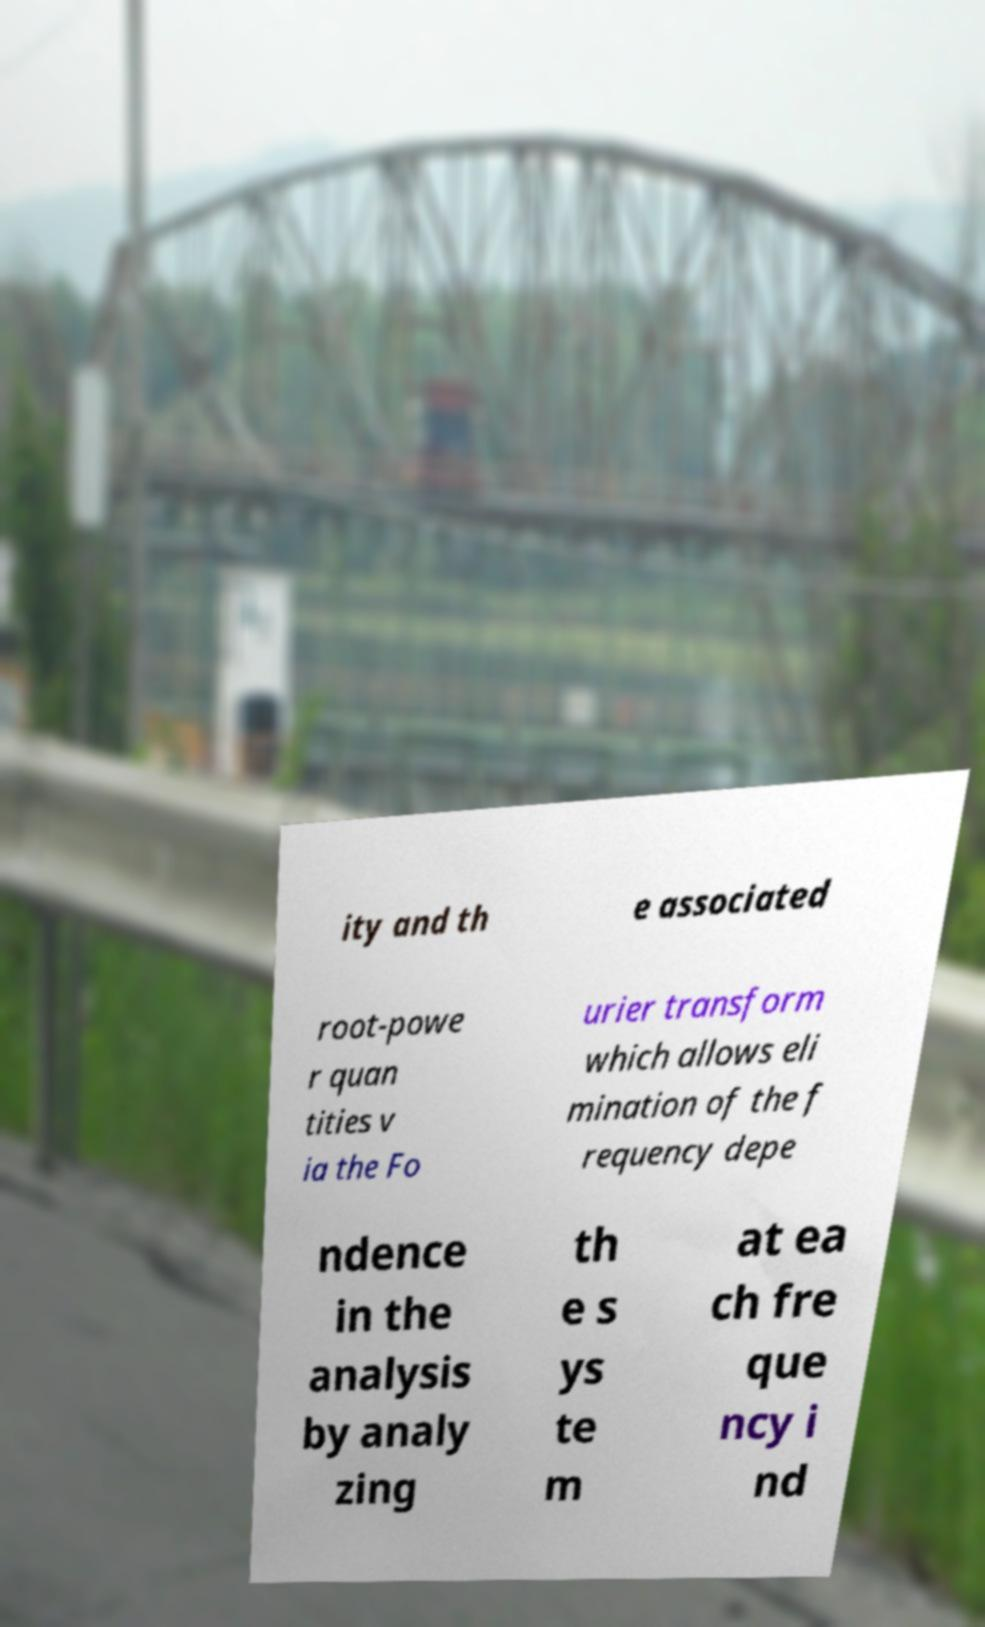Could you assist in decoding the text presented in this image and type it out clearly? ity and th e associated root-powe r quan tities v ia the Fo urier transform which allows eli mination of the f requency depe ndence in the analysis by analy zing th e s ys te m at ea ch fre que ncy i nd 